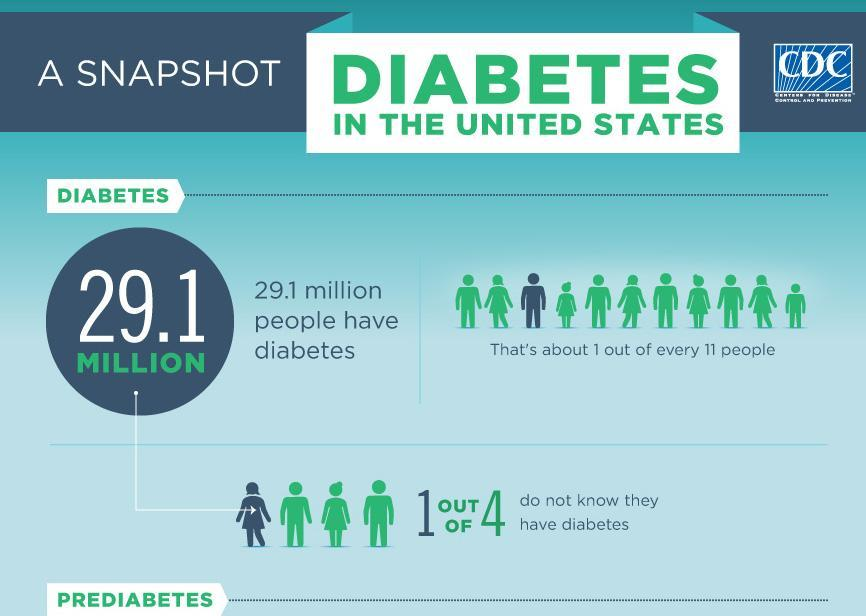what percentage of people do not know they have diabetes
Answer the question with a short phrase. 25 what percentage of people know that they have diabetes 75 what disease is being discussed diabetes 